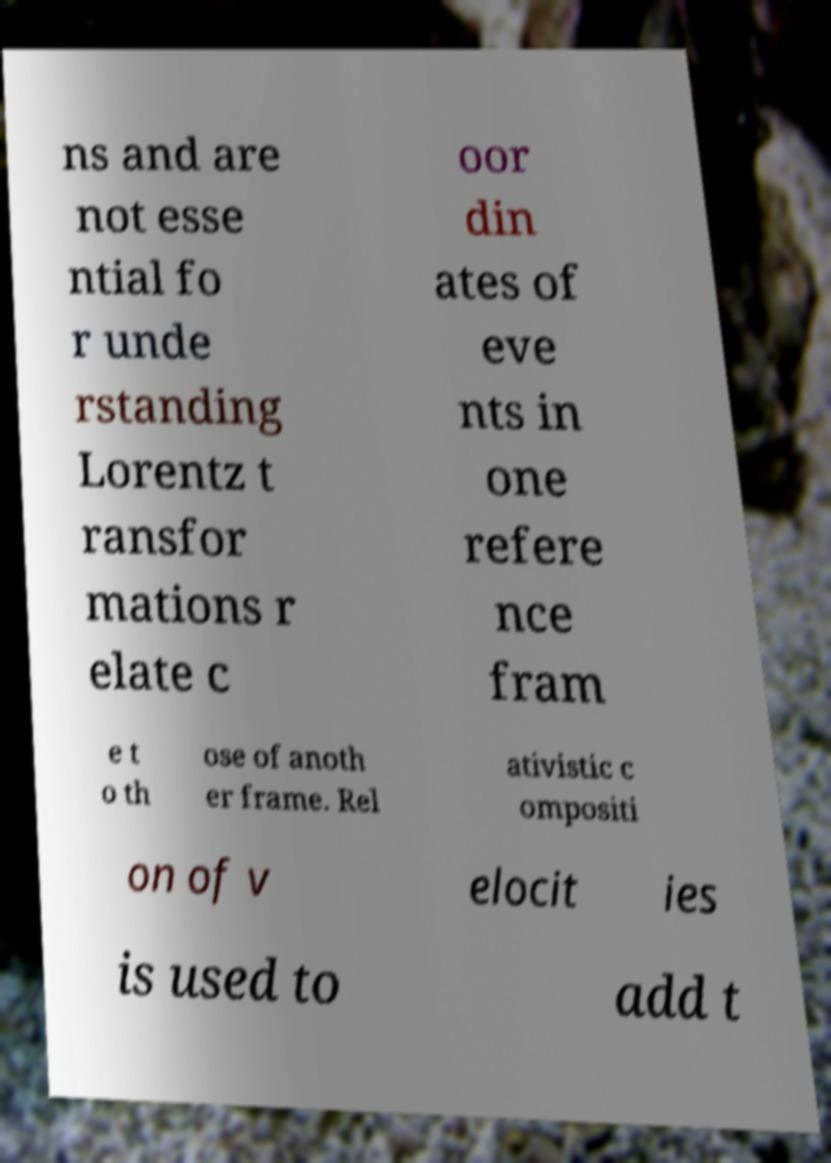For documentation purposes, I need the text within this image transcribed. Could you provide that? ns and are not esse ntial fo r unde rstanding Lorentz t ransfor mations r elate c oor din ates of eve nts in one refere nce fram e t o th ose of anoth er frame. Rel ativistic c ompositi on of v elocit ies is used to add t 